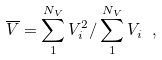<formula> <loc_0><loc_0><loc_500><loc_500>\overline { V } = \sum _ { 1 } ^ { N _ { V } } V _ { i } ^ { 2 } / \sum _ { 1 } ^ { N _ { V } } V _ { i } \ ,</formula> 